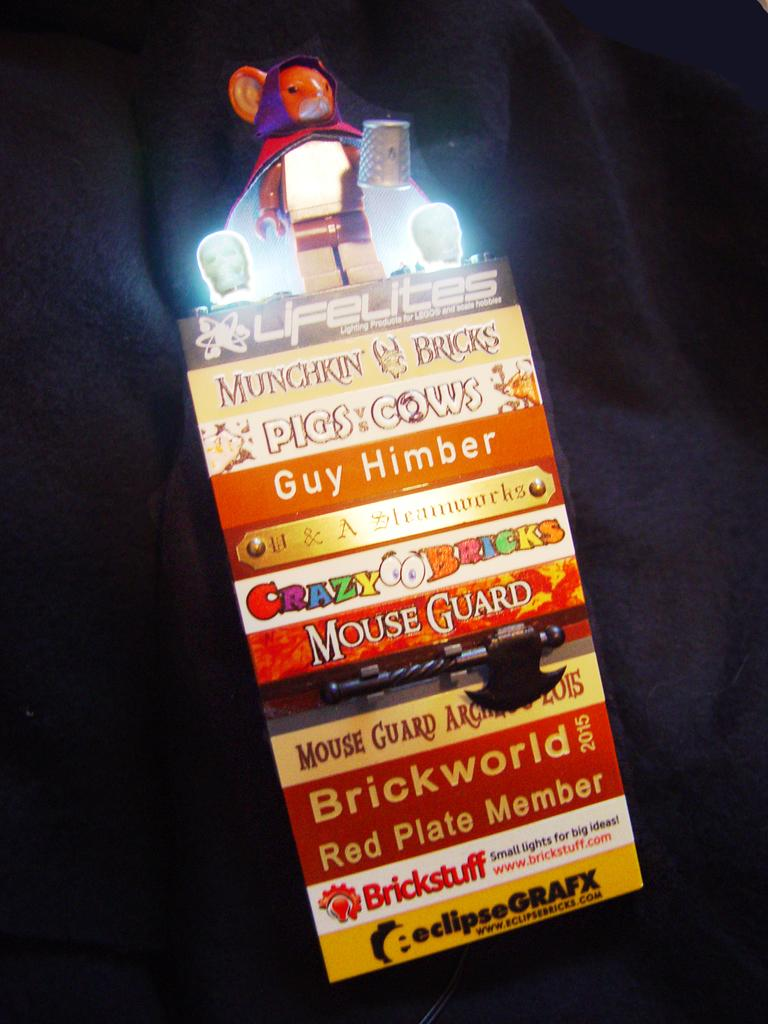What type of object is on the board in the image? There is a weapon on the board. What else can be seen on the board besides the weapon? There are lights and a toy on the board. What color is the background of the board? The background of the board is black. Can you tell me how many firemen are present in the image? There are no firemen present in the image; it features a board with a weapon, lights, and a toy on a black background. What type of seed can be seen growing on the board? There are no seeds present in the image; it features a board with a weapon, lights, and a toy on a black background. 